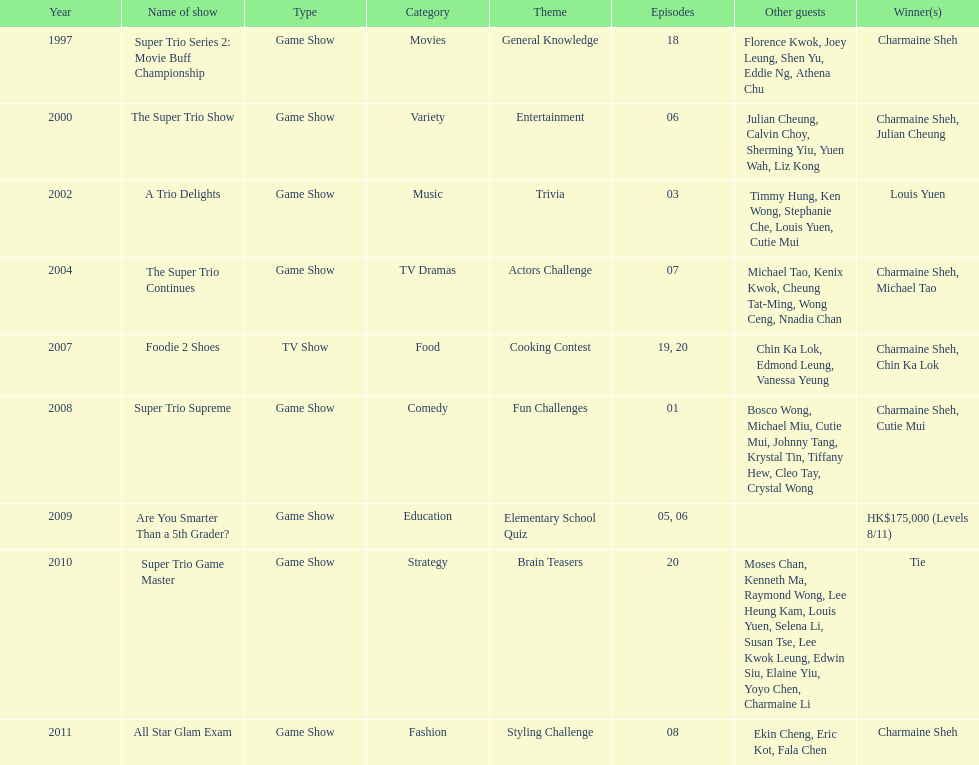How many times has charmaine sheh won on a variety show? 6. Could you help me parse every detail presented in this table? {'header': ['Year', 'Name of show', 'Type', 'Category', 'Theme', 'Episodes', 'Other guests', 'Winner(s)'], 'rows': [['1997', 'Super Trio Series 2: Movie Buff Championship', 'Game Show', 'Movies', 'General Knowledge', '18', 'Florence Kwok, Joey Leung, Shen Yu, Eddie Ng, Athena Chu', 'Charmaine Sheh'], ['2000', 'The Super Trio Show', 'Game Show', 'Variety', 'Entertainment', '06', 'Julian Cheung, Calvin Choy, Sherming Yiu, Yuen Wah, Liz Kong', 'Charmaine Sheh, Julian Cheung'], ['2002', 'A Trio Delights', 'Game Show', 'Music', 'Trivia', '03', 'Timmy Hung, Ken Wong, Stephanie Che, Louis Yuen, Cutie Mui', 'Louis Yuen'], ['2004', 'The Super Trio Continues', 'Game Show', 'TV Dramas', 'Actors Challenge', '07', 'Michael Tao, Kenix Kwok, Cheung Tat-Ming, Wong Ceng, Nnadia Chan', 'Charmaine Sheh, Michael Tao'], ['2007', 'Foodie 2 Shoes', 'TV Show', 'Food', 'Cooking Contest', '19, 20', 'Chin Ka Lok, Edmond Leung, Vanessa Yeung', 'Charmaine Sheh, Chin Ka Lok'], ['2008', 'Super Trio Supreme', 'Game Show', 'Comedy', 'Fun Challenges', '01', 'Bosco Wong, Michael Miu, Cutie Mui, Johnny Tang, Krystal Tin, Tiffany Hew, Cleo Tay, Crystal Wong', 'Charmaine Sheh, Cutie Mui'], ['2009', 'Are You Smarter Than a 5th Grader?', 'Game Show', 'Education', 'Elementary School Quiz', '05, 06', '', 'HK$175,000 (Levels 8/11)'], ['2010', 'Super Trio Game Master', 'Game Show', 'Strategy', 'Brain Teasers', '20', 'Moses Chan, Kenneth Ma, Raymond Wong, Lee Heung Kam, Louis Yuen, Selena Li, Susan Tse, Lee Kwok Leung, Edwin Siu, Elaine Yiu, Yoyo Chen, Charmaine Li', 'Tie'], ['2011', 'All Star Glam Exam', 'Game Show', 'Fashion', 'Styling Challenge', '08', 'Ekin Cheng, Eric Kot, Fala Chen', 'Charmaine Sheh']]} 